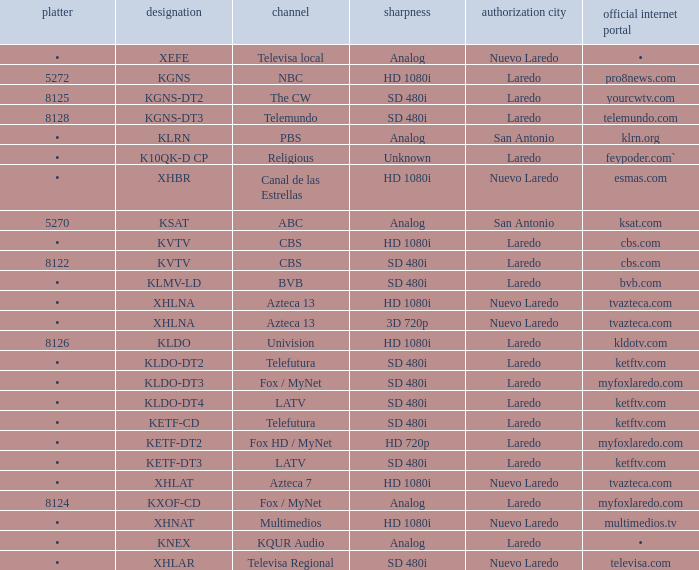Name the dish for resolution of sd 480i and network of bvb •. 